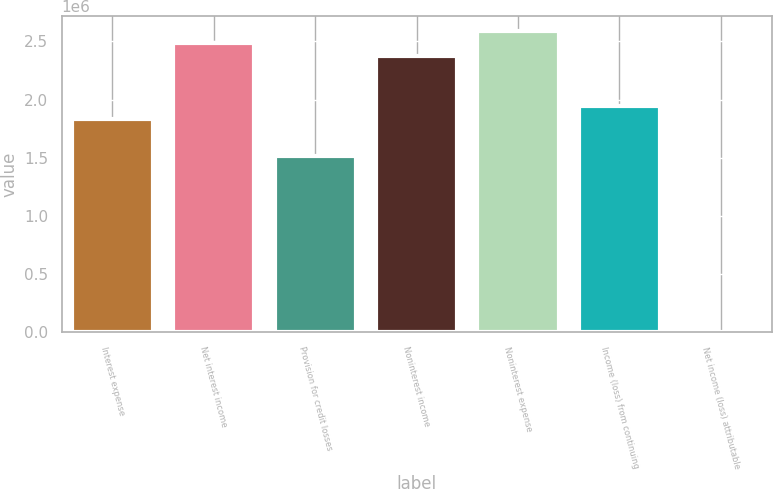Convert chart to OTSL. <chart><loc_0><loc_0><loc_500><loc_500><bar_chart><fcel>Interest expense<fcel>Net interest income<fcel>Provision for credit losses<fcel>Noninterest income<fcel>Noninterest expense<fcel>Income (loss) from continuing<fcel>Net income (loss) attributable<nl><fcel>1.83486e+06<fcel>2.48246e+06<fcel>1.51106e+06<fcel>2.37453e+06<fcel>2.59039e+06<fcel>1.94279e+06<fcel>0.17<nl></chart> 